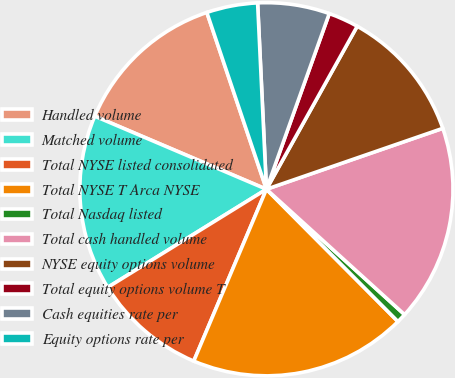<chart> <loc_0><loc_0><loc_500><loc_500><pie_chart><fcel>Handled volume<fcel>Matched volume<fcel>Total NYSE listed consolidated<fcel>Total NYSE T Arca NYSE<fcel>Total Nasdaq listed<fcel>Total cash handled volume<fcel>NYSE equity options volume<fcel>Total equity options volume T<fcel>Cash equities rate per<fcel>Equity options rate per<nl><fcel>13.42%<fcel>15.22%<fcel>9.82%<fcel>18.82%<fcel>0.82%<fcel>17.02%<fcel>11.62%<fcel>2.62%<fcel>6.22%<fcel>4.42%<nl></chart> 